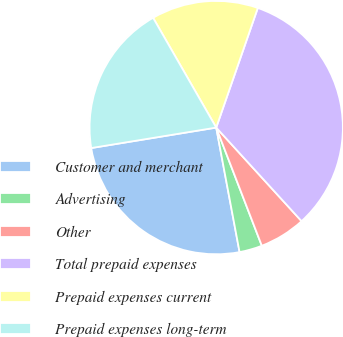<chart> <loc_0><loc_0><loc_500><loc_500><pie_chart><fcel>Customer and merchant<fcel>Advertising<fcel>Other<fcel>Total prepaid expenses<fcel>Prepaid expenses current<fcel>Prepaid expenses long-term<nl><fcel>25.37%<fcel>2.91%<fcel>5.91%<fcel>32.91%<fcel>13.63%<fcel>19.28%<nl></chart> 